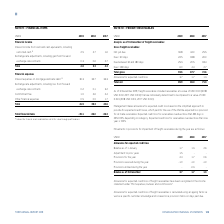According to Torm's financial document, What is the total financial income for 2019? According to the financial document, 2.8 (in millions). The relevant text states: "Total 2.8 3.3 4.3..." Also, What is the amount of total financial items in 2019? According to the financial document, -39.1 (in millions). The relevant text states: "Total financial items -39.1 -36.0 -36.3..." Also, What are the main categories analyzed under Financial Items in the table? The document shows two values: Financial income and Financial expenses. From the document: "Financial income Financial expenses..." Additionally, In which year was the amount of financial income the smallest? According to the financial document, 2019. The relevant text states: "USDm 2019 2018 2017..." Also, can you calculate: What was the change in total financial expenses in 2019 from 2018? Based on the calculation: 41.9-39.3, the result is 2.6 (in millions). This is based on the information: "Total 41.9 39.3 40.6 Total 41.9 39.3 40.6..." The key data points involved are: 39.3, 41.9. Also, can you calculate: What was the percentage change in total financial expenses in 2019 from 2018? To answer this question, I need to perform calculations using the financial data. The calculation is: (41.9-39.3)/39.3, which equals 6.62 (percentage). This is based on the information: "Total 41.9 39.3 40.6 Total 41.9 39.3 40.6..." The key data points involved are: 39.3, 41.9. 